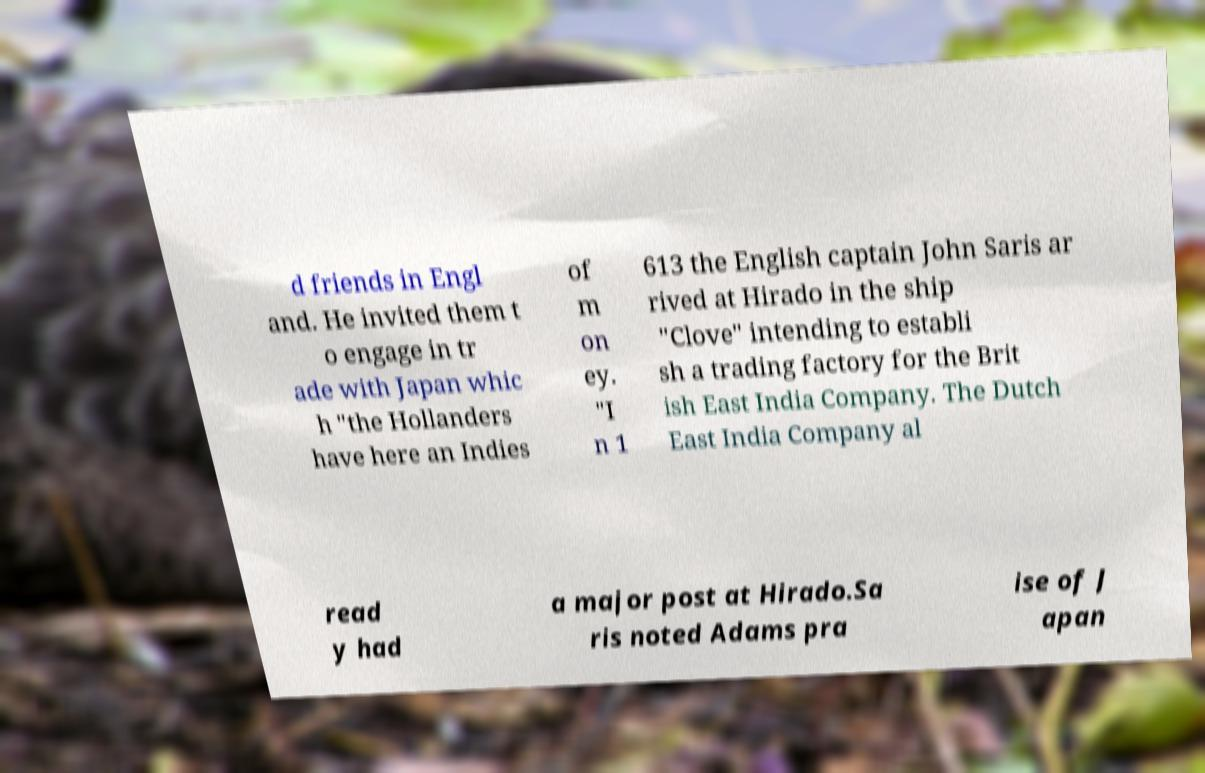Could you assist in decoding the text presented in this image and type it out clearly? d friends in Engl and. He invited them t o engage in tr ade with Japan whic h "the Hollanders have here an Indies of m on ey. "I n 1 613 the English captain John Saris ar rived at Hirado in the ship "Clove" intending to establi sh a trading factory for the Brit ish East India Company. The Dutch East India Company al read y had a major post at Hirado.Sa ris noted Adams pra ise of J apan 